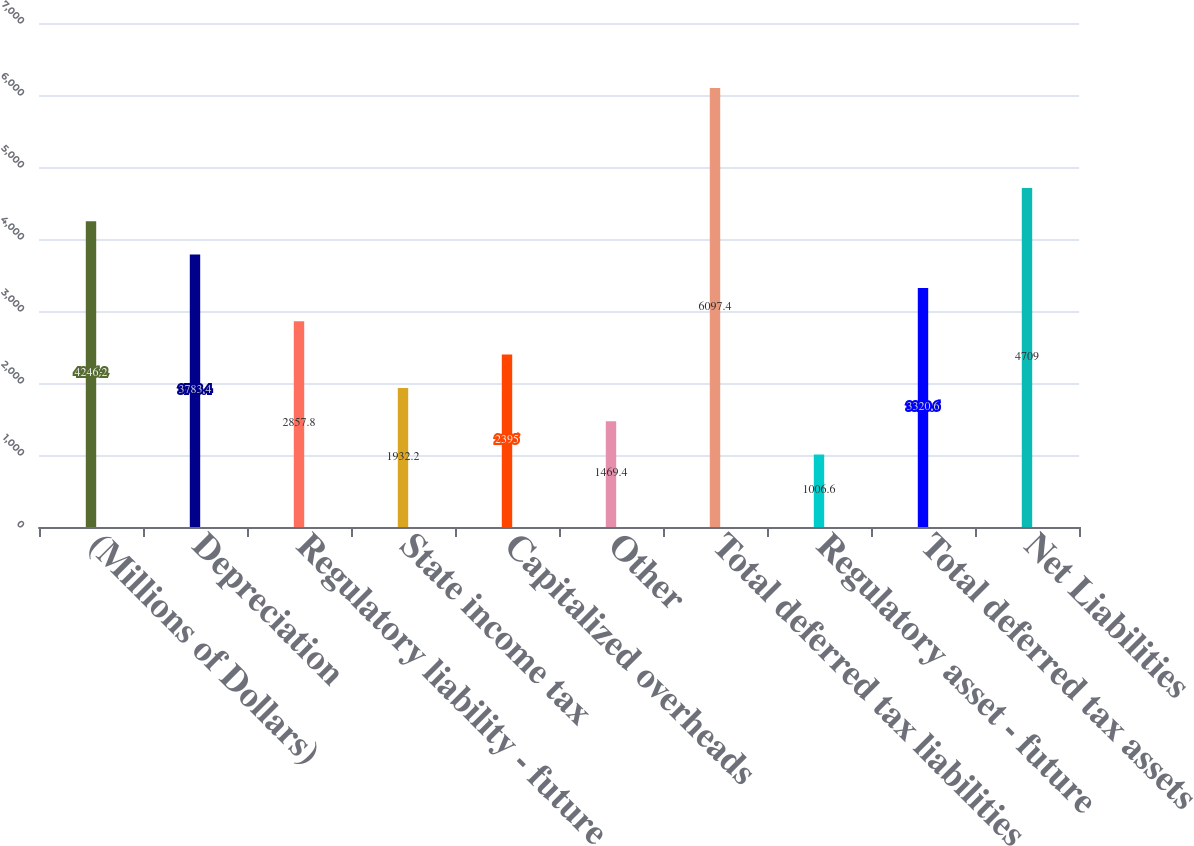Convert chart. <chart><loc_0><loc_0><loc_500><loc_500><bar_chart><fcel>(Millions of Dollars)<fcel>Depreciation<fcel>Regulatory liability - future<fcel>State income tax<fcel>Capitalized overheads<fcel>Other<fcel>Total deferred tax liabilities<fcel>Regulatory asset - future<fcel>Total deferred tax assets<fcel>Net Liabilities<nl><fcel>4246.2<fcel>3783.4<fcel>2857.8<fcel>1932.2<fcel>2395<fcel>1469.4<fcel>6097.4<fcel>1006.6<fcel>3320.6<fcel>4709<nl></chart> 